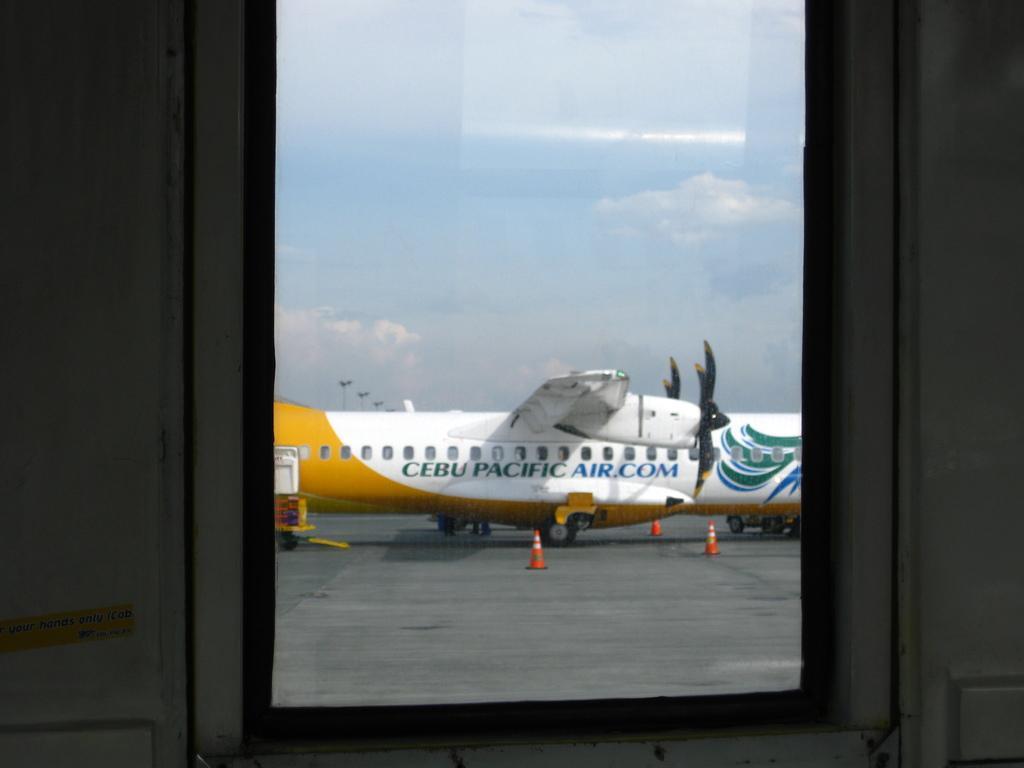Please provide a concise description of this image. It is a glass, outside there is an aeroplane, it is in white and yellow color. At the top it's a sky. 